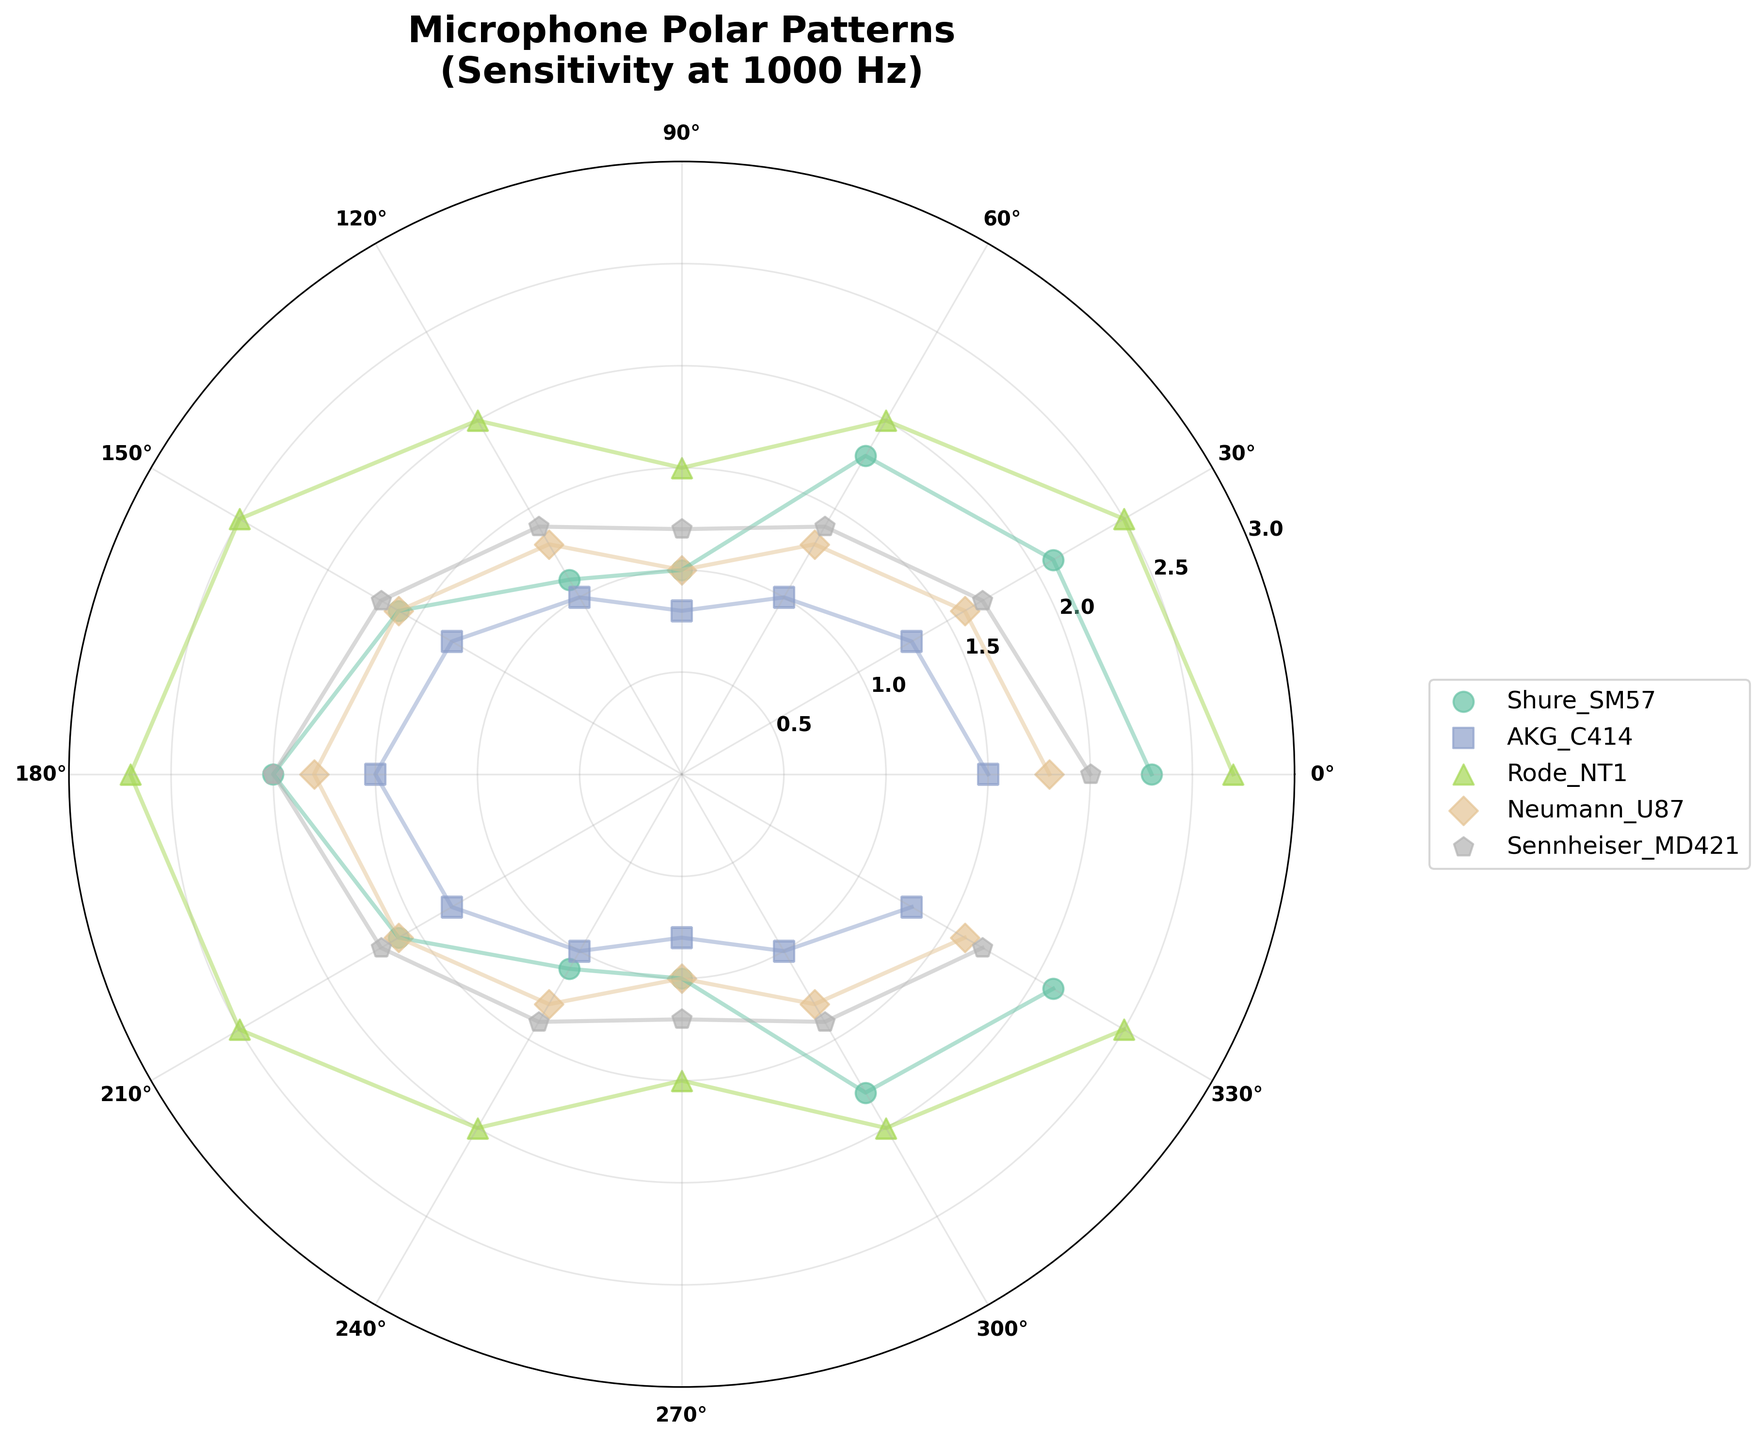What is the title of the figure? The title is located at the top of the figure and reads 'Microphone Polar Patterns\n(Sensitivity at 1000 Hz)'. This provides a summary of what the figure represents, such as the polar patterns of different microphones with their sensitivity at 1000 Hz.
Answer: Microphone Polar Patterns (Sensitivity at 1000 Hz) How many different microphones are compared in the figure? By counting the unique microphone names in the legend on the right side of the figure, we can see that there are five different microphones compared: Shure_SM57, AKG_C414, Rode_NT1, Neumann_U87, and Sennheiser_MD421.
Answer: Five Which microphone shows the highest sensitivity and at what angle? By examining the scatter points, the Rode_NT1 shows the highest sensitivity, which is 2.7, occurring at the angles of 0 and 180 degrees.
Answer: Rode_NT1 at 0° and 180° Which microphone has the lowest sensitivity at 90 degrees? To find this, look at the points on the plot at 90 degrees (clockwise from the vertical axis) and compare their sensitivity values. The AKG_C414 has the lowest sensitivity at 90 degrees, which is 0.8.
Answer: AKG_C414 What's the total sensitivity of the Shure_SM57 microphone across all angles? To calculate this, sum the sensitivity values of Shure_SM57 at each angle: 2.3 + 2.1 + 1.8 + 1.0 + 1.1 + 1.6 + 2.0 + 1.6 + 1.1 + 1.0 + 1.8 + 2.1. This totals 19.5.
Answer: 19.5 Which microphone has a symmetrical polar pattern and what does it indicate? By observing the scatter points and their symmetry around the 180-degree line, the Rode_NT1 appears to have a symmetrical pattern, indicated by the equal sensitivity values at corresponding angles (e.g., 0° & 180°, 30° & 330°). This suggests the microphone has consistent sensitivity in opposite directions.
Answer: Rode_NT1 Between Neumann_U87 and Sennheiser_MD421, which microphone shows a greater variation in sensitivity? The variation can be determined by identifying the range (difference between max and min values) for each microphone. For Neumann_U87, the max is 1.8 and the min is 1.0, making the range 0.8. For Sennheiser_MD421, the range is from 2.0 to 1.2, which is 0.8. Both microphones have the same variation in sensitivity.
Answer: Equal (0.8) Which angle shows the highest average sensitivity across all microphones? Calculate the average sensitivity for each angle across all microphones: (2.3+1.5+2.7+1.8+2.0 at 0°; 2.1+1.3+2.5+1.6+1.7 at 30°; and so on). The angle with the highest average sensitivity is 0°, with an average of 2.06.
Answer: 0° What is the pattern of the Shure_SM57 microphone's sensitivity as it moves from 0 degrees to 180 degrees, and how does this pattern compare when it moves from 180 degrees back to 0 degrees? The Shure_SM57 sensitivity decreases from 2.3 to 2.0 between 0° to 180°. As it moves back from 180° to 0°, it regains similar values at corresponding angles (symmetrical pattern). This symmetry indicates a consistent polar pattern across both halves, typical of certain cardioid microphones.
Answer: Symmetrical pattern 